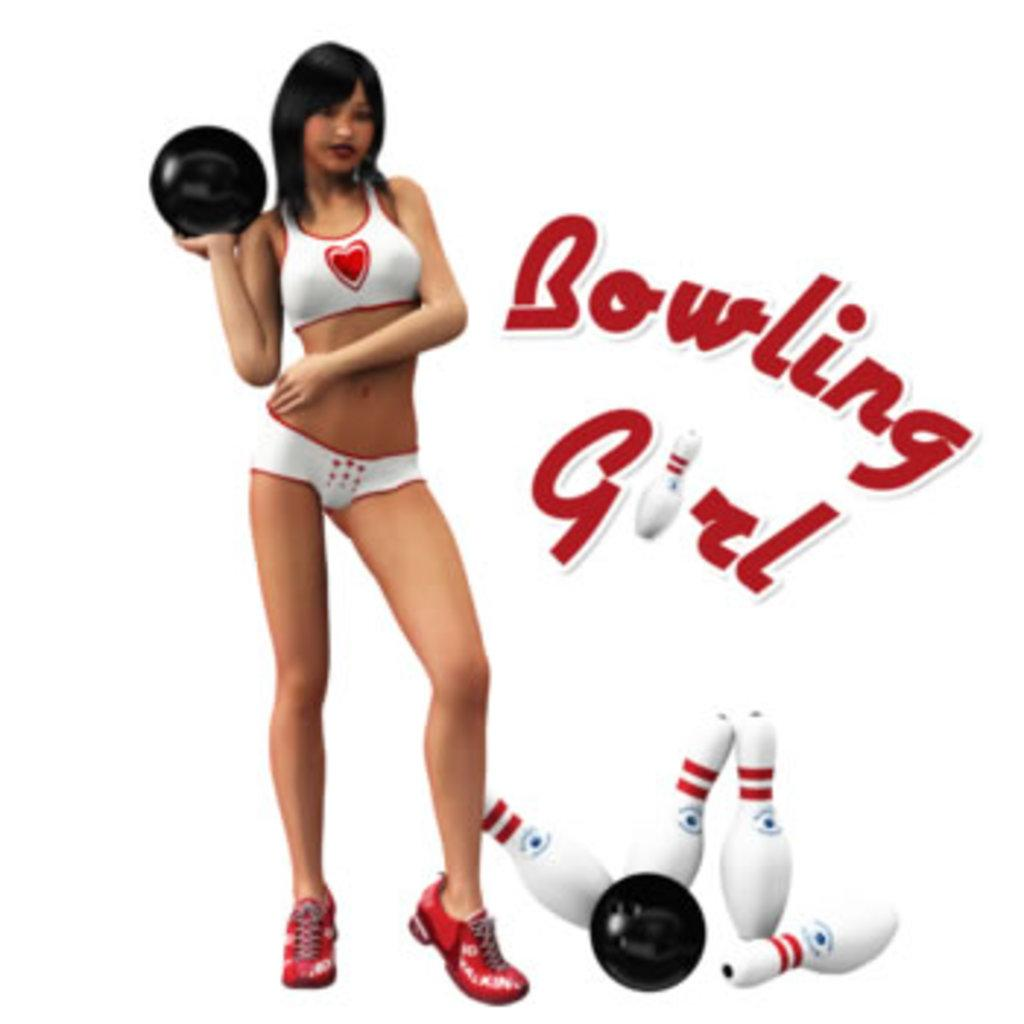Provide a one-sentence caption for the provided image. a bowling girl ad that some pins on it. 